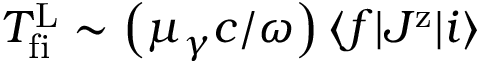Convert formula to latex. <formula><loc_0><loc_0><loc_500><loc_500>T _ { f i } ^ { L } \sim \left ( \mu _ { \gamma } c / \omega \right ) \langle f | J ^ { z } | i \rangle</formula> 